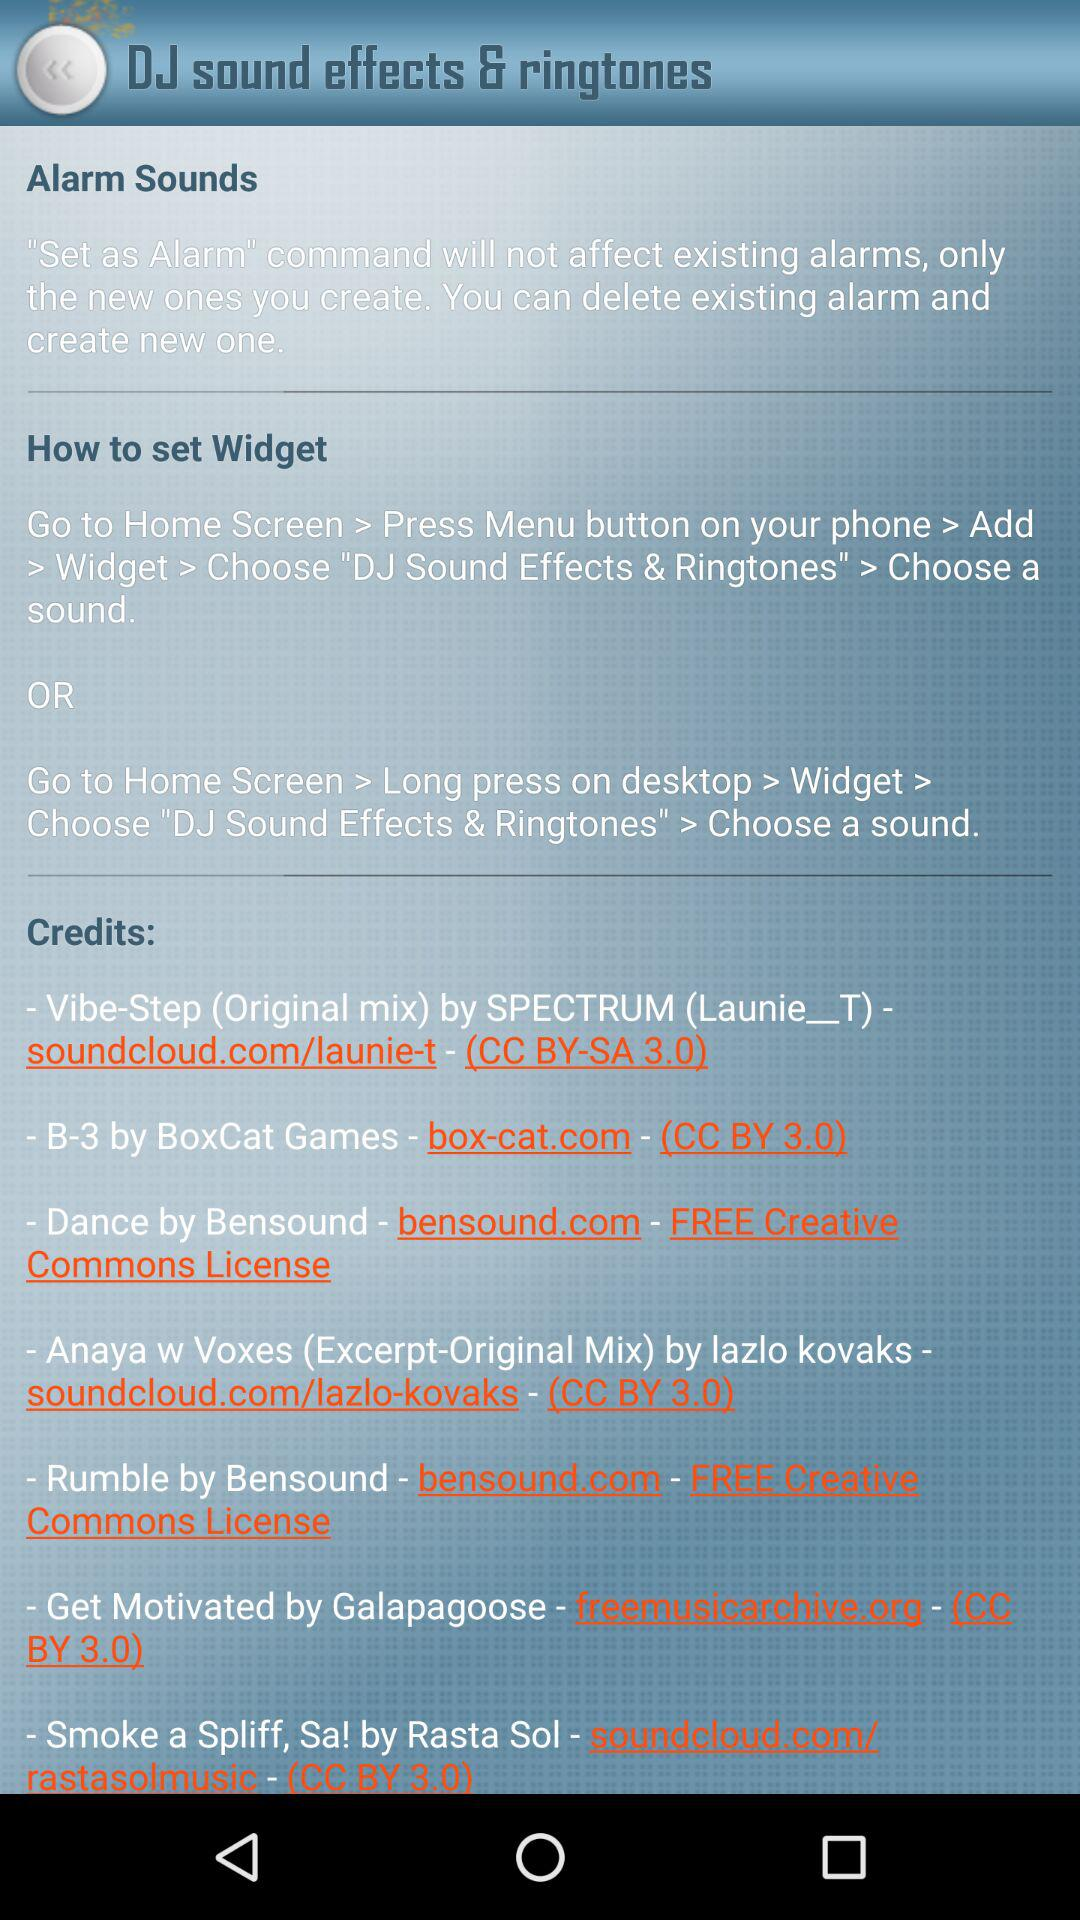What are the steps to setting up a widget? The steps to setting up a widget are "Go to Home Screen > Press Menu button on your phone > Add > Widget > Choose "DJ Sound Effects & Ringtones" > Choose a sound." or "Go to Home Screen > Long press on desktop > Widget > Choose "DJ Sound Effects & Ringtones" > Choose a sound". 